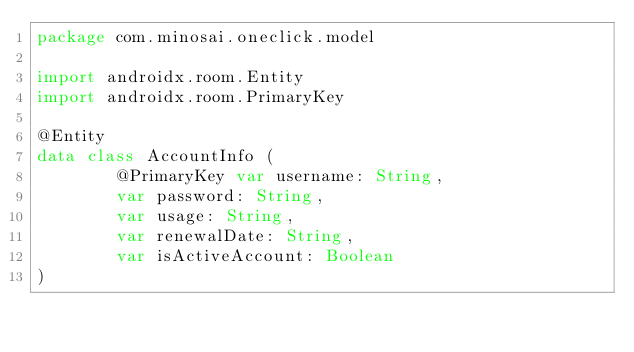<code> <loc_0><loc_0><loc_500><loc_500><_Kotlin_>package com.minosai.oneclick.model

import androidx.room.Entity
import androidx.room.PrimaryKey

@Entity
data class AccountInfo (
        @PrimaryKey var username: String,
        var password: String,
        var usage: String,
        var renewalDate: String,
        var isActiveAccount: Boolean
)</code> 